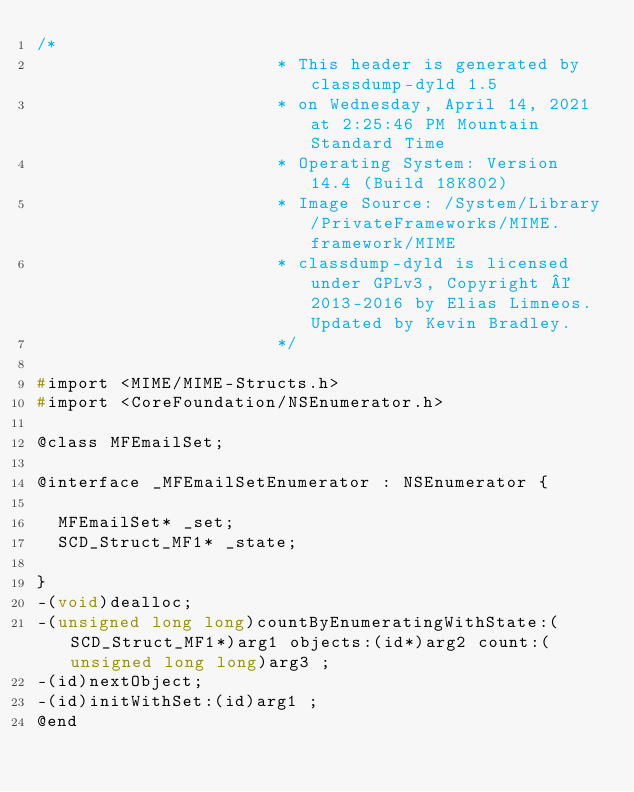Convert code to text. <code><loc_0><loc_0><loc_500><loc_500><_C_>/*
                       * This header is generated by classdump-dyld 1.5
                       * on Wednesday, April 14, 2021 at 2:25:46 PM Mountain Standard Time
                       * Operating System: Version 14.4 (Build 18K802)
                       * Image Source: /System/Library/PrivateFrameworks/MIME.framework/MIME
                       * classdump-dyld is licensed under GPLv3, Copyright © 2013-2016 by Elias Limneos. Updated by Kevin Bradley.
                       */

#import <MIME/MIME-Structs.h>
#import <CoreFoundation/NSEnumerator.h>

@class MFEmailSet;

@interface _MFEmailSetEnumerator : NSEnumerator {

	MFEmailSet* _set;
	SCD_Struct_MF1* _state;

}
-(void)dealloc;
-(unsigned long long)countByEnumeratingWithState:(SCD_Struct_MF1*)arg1 objects:(id*)arg2 count:(unsigned long long)arg3 ;
-(id)nextObject;
-(id)initWithSet:(id)arg1 ;
@end

</code> 